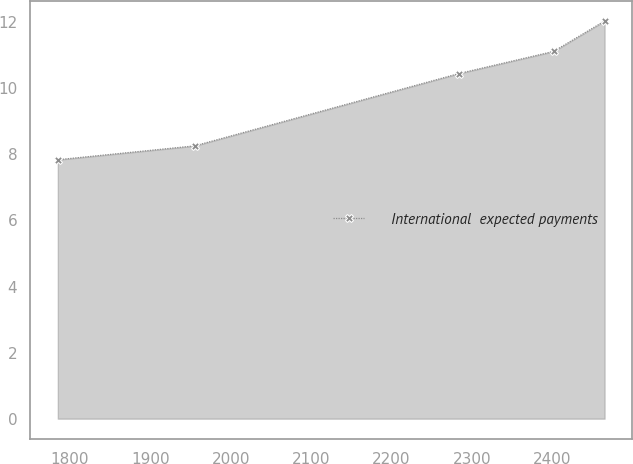<chart> <loc_0><loc_0><loc_500><loc_500><line_chart><ecel><fcel>International  expected payments<nl><fcel>1784.78<fcel>7.84<nl><fcel>1955.19<fcel>8.26<nl><fcel>2284.16<fcel>10.45<nl><fcel>2402.02<fcel>11.12<nl><fcel>2465.44<fcel>12.04<nl></chart> 